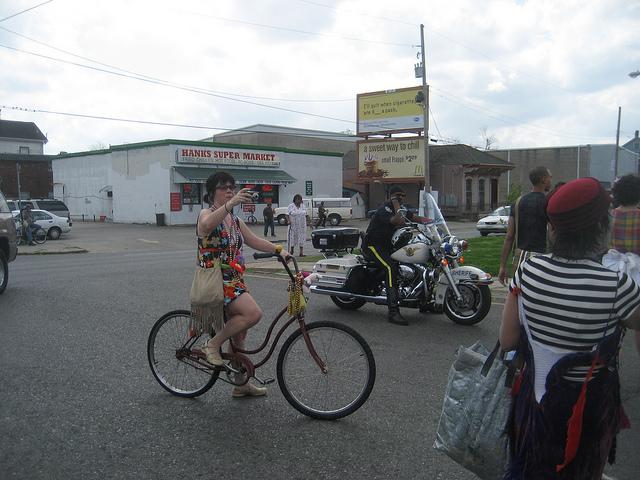Why is the bike connected to the pole?
Quick response, please. Parked. Are there markings on the pavement?
Short answer required. No. What type of building is this?
Quick response, please. Store. What is on the woman's head?
Write a very short answer. Hat. Are the bikes moving?
Quick response, please. No. Is this bike designed to race?
Give a very brief answer. No. How many motorcycles can be seen?
Write a very short answer. 1. Is this a customized bike?
Answer briefly. No. Why is her outfit impractical for this activity?
Answer briefly. Too short. Which bike is faster?
Keep it brief. Motorcycle. What pattern is on the girl's outfit who is on the bike?
Write a very short answer. Floral. Whose bike is this?
Answer briefly. Hers. What is the lady wearing?
Give a very brief answer. Dress. What does the neon sign read?
Short answer required. Open. What are square colorful objects behind the motorcycles?
Write a very short answer. Signs. Which man has a red hat?
Concise answer only. Right. What are the two streets at this intersection?
Short answer required. 0. What kind of bike is shown?
Write a very short answer. Bicycle. 